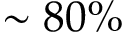Convert formula to latex. <formula><loc_0><loc_0><loc_500><loc_500>\sim 8 0 \%</formula> 